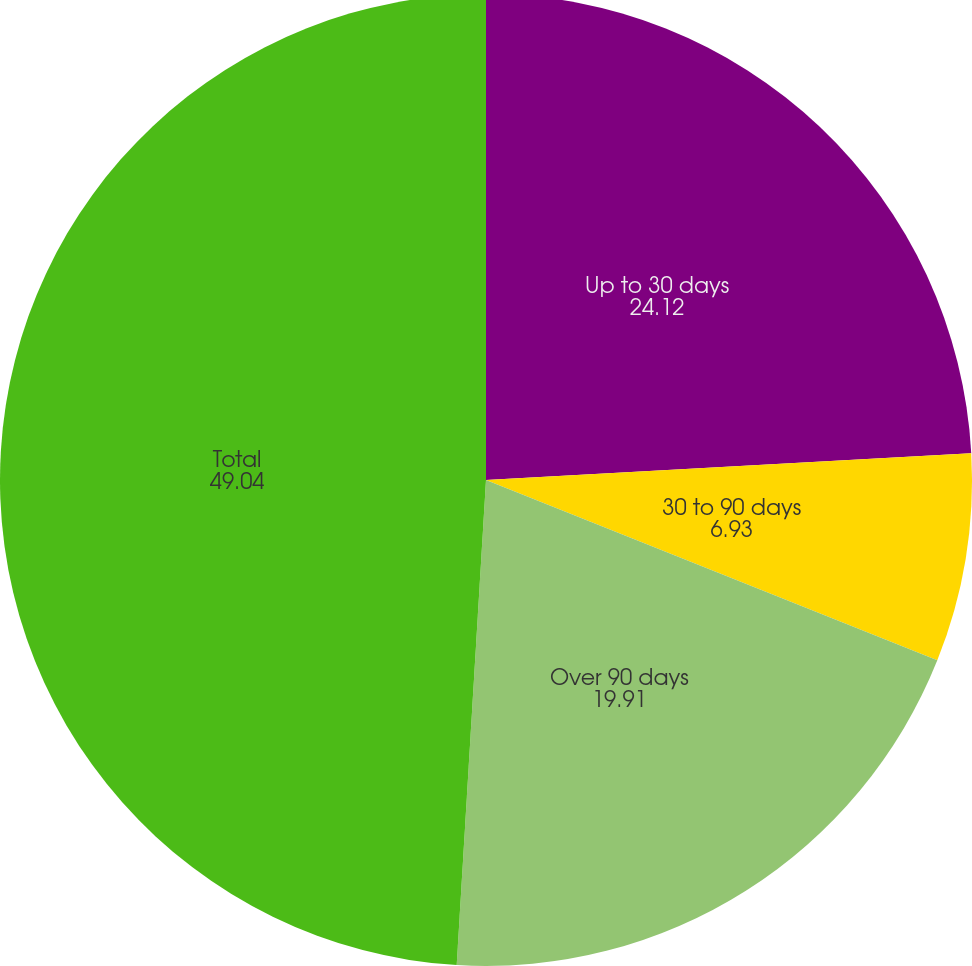<chart> <loc_0><loc_0><loc_500><loc_500><pie_chart><fcel>Up to 30 days<fcel>30 to 90 days<fcel>Over 90 days<fcel>Total<nl><fcel>24.12%<fcel>6.93%<fcel>19.91%<fcel>49.04%<nl></chart> 